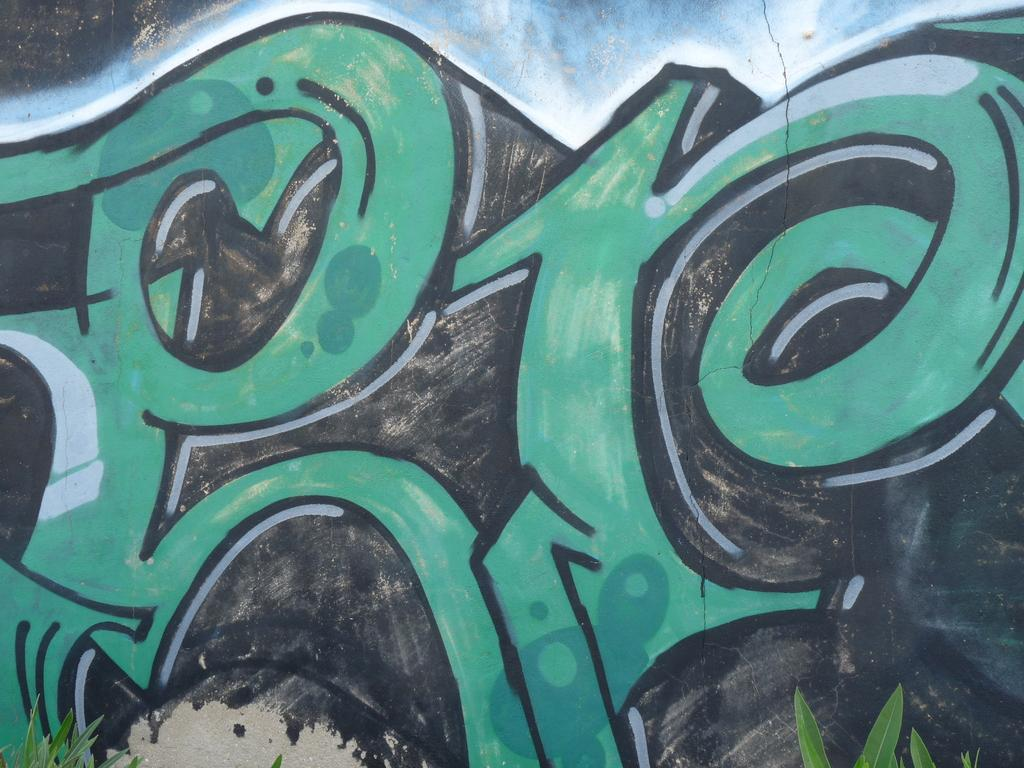What is hanging on the wall in the image? There is a painting on the wall in the image. What can be seen at the bottom of the image? There are plants at the bottom of the image. Can you see a list of items floating in the ocean in the image? There is no ocean or list of items present in the image. 